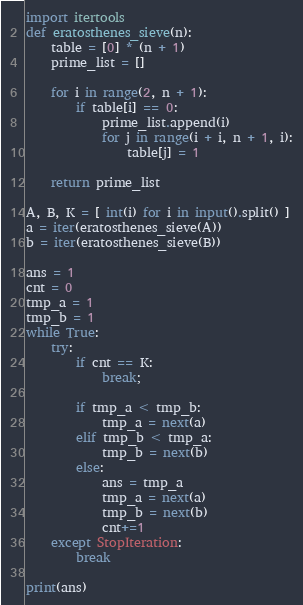Convert code to text. <code><loc_0><loc_0><loc_500><loc_500><_Python_>import itertools
def eratosthenes_sieve(n):
    table = [0] * (n + 1)
    prime_list = []

    for i in range(2, n + 1):
        if table[i] == 0:
            prime_list.append(i)
            for j in range(i + i, n + 1, i):
                table[j] = 1

    return prime_list

A, B, K = [ int(i) for i in input().split() ]
a = iter(eratosthenes_sieve(A))
b = iter(eratosthenes_sieve(B))

ans = 1
cnt = 0
tmp_a = 1
tmp_b = 1
while True:
    try:
        if cnt == K:
            break;

        if tmp_a < tmp_b:
            tmp_a = next(a)
        elif tmp_b < tmp_a:
            tmp_b = next(b)
        else:
            ans = tmp_a
            tmp_a = next(a)
            tmp_b = next(b)
            cnt+=1
    except StopIteration:
        break

print(ans)



</code> 